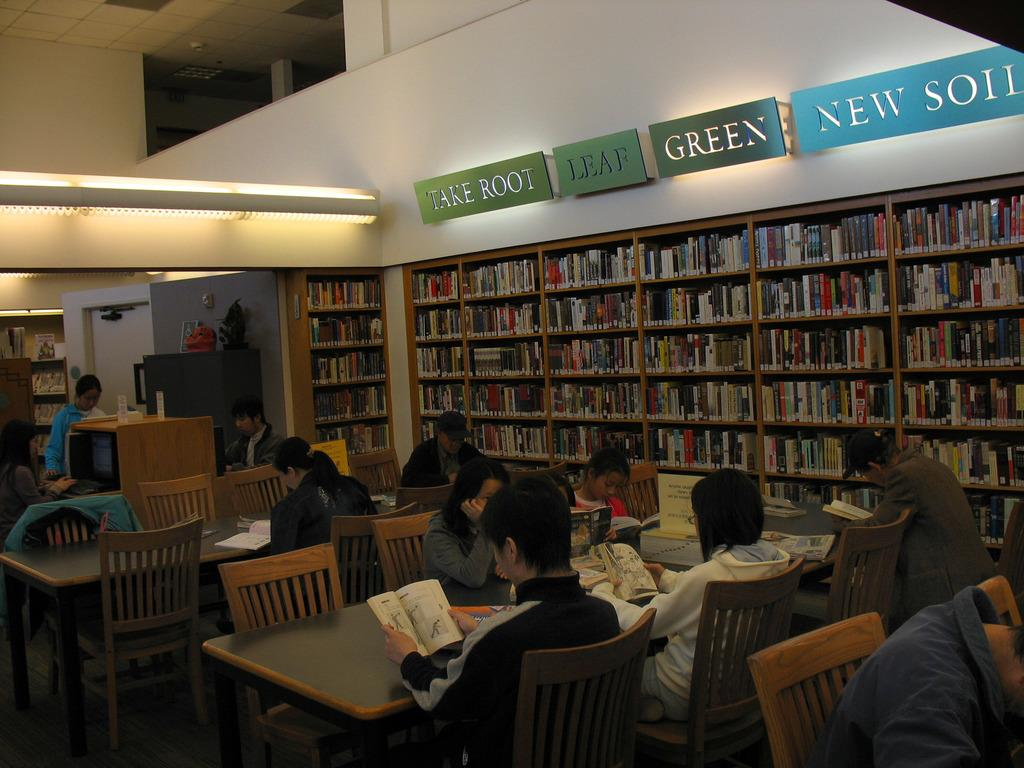What are the people in the image doing? There is a group of people sitting in chairs in the image. What can be seen in the background of the image? In the background, there is a name board, books in racks, a table, a chair, a plant, and a light. Can you describe the setting where the people are sitting? The setting appears to be a room with chairs, a table, and books in racks, suggesting it might be a classroom or library. Can you see a crow sitting on the swing in the image? There is no crow or swing present in the image. What color is the feather that is falling near the plant in the image? There is no feather present in the image. 